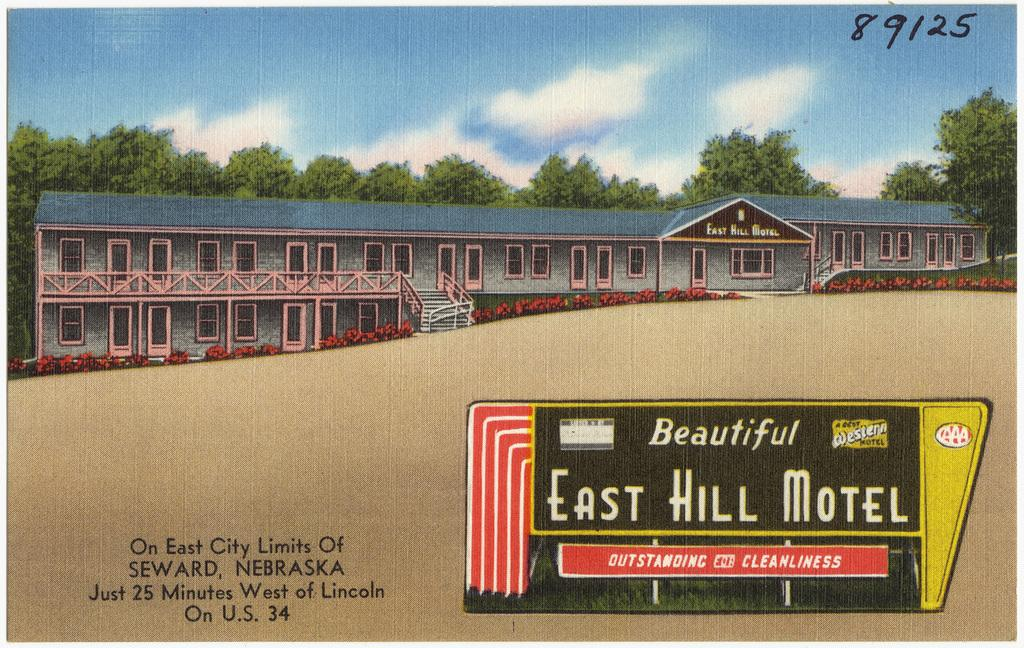<image>
Render a clear and concise summary of the photo. an image of the east hill motel in nebraska 